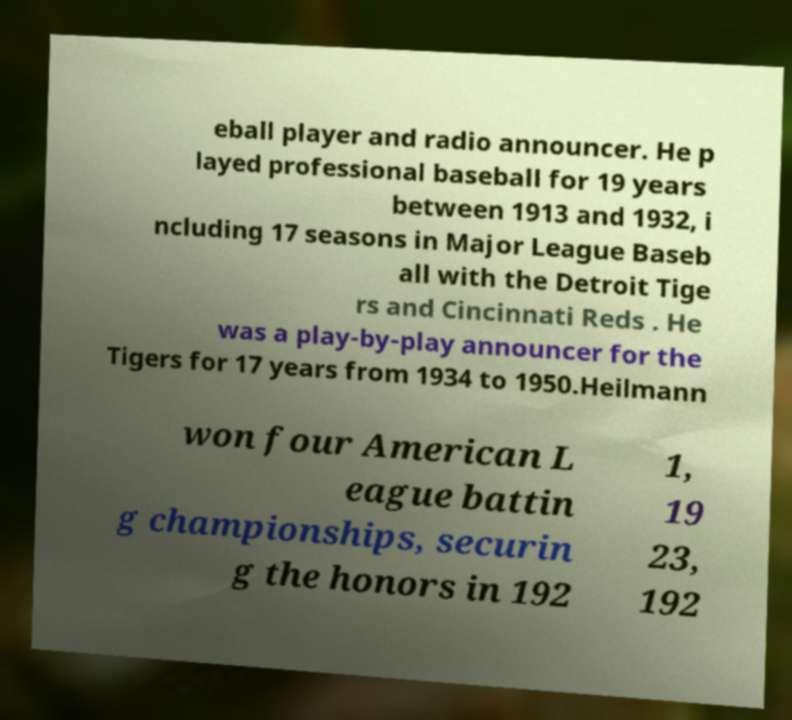Could you extract and type out the text from this image? eball player and radio announcer. He p layed professional baseball for 19 years between 1913 and 1932, i ncluding 17 seasons in Major League Baseb all with the Detroit Tige rs and Cincinnati Reds . He was a play-by-play announcer for the Tigers for 17 years from 1934 to 1950.Heilmann won four American L eague battin g championships, securin g the honors in 192 1, 19 23, 192 